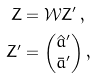Convert formula to latex. <formula><loc_0><loc_0><loc_500><loc_500>Z & = \mathcal { W } Z ^ { \prime } \, , \\ Z ^ { \prime } & = \begin{pmatrix} \hat { a } ^ { \prime } \\ \bar { a } ^ { \prime } \end{pmatrix} ,</formula> 